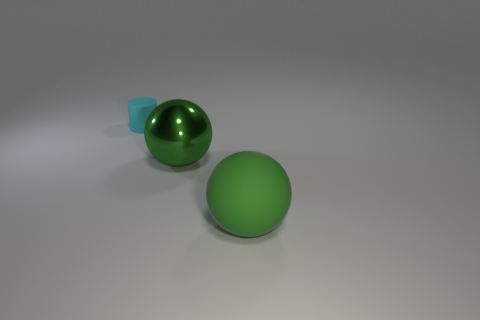What shape is the thing that is the same color as the rubber ball?
Make the answer very short. Sphere. How many things are either things that are to the left of the big green matte object or green rubber spheres?
Provide a succinct answer. 3. What is the size of the object that is to the left of the large green matte sphere and in front of the cyan thing?
Give a very brief answer. Large. What is the size of the ball that is the same color as the large metallic object?
Keep it short and to the point. Large. What number of other things are there of the same size as the green rubber ball?
Offer a terse response. 1. What is the color of the object that is to the right of the sphere behind the big ball in front of the large shiny sphere?
Your response must be concise. Green. There is a object that is both right of the cyan thing and left of the large green matte thing; what is its shape?
Ensure brevity in your answer.  Sphere. How many other objects are the same shape as the small cyan matte object?
Ensure brevity in your answer.  0. The matte thing in front of the rubber thing that is behind the rubber object that is on the right side of the tiny cyan matte object is what shape?
Make the answer very short. Sphere. How many objects are small brown spheres or green things that are right of the green metal ball?
Ensure brevity in your answer.  1. 